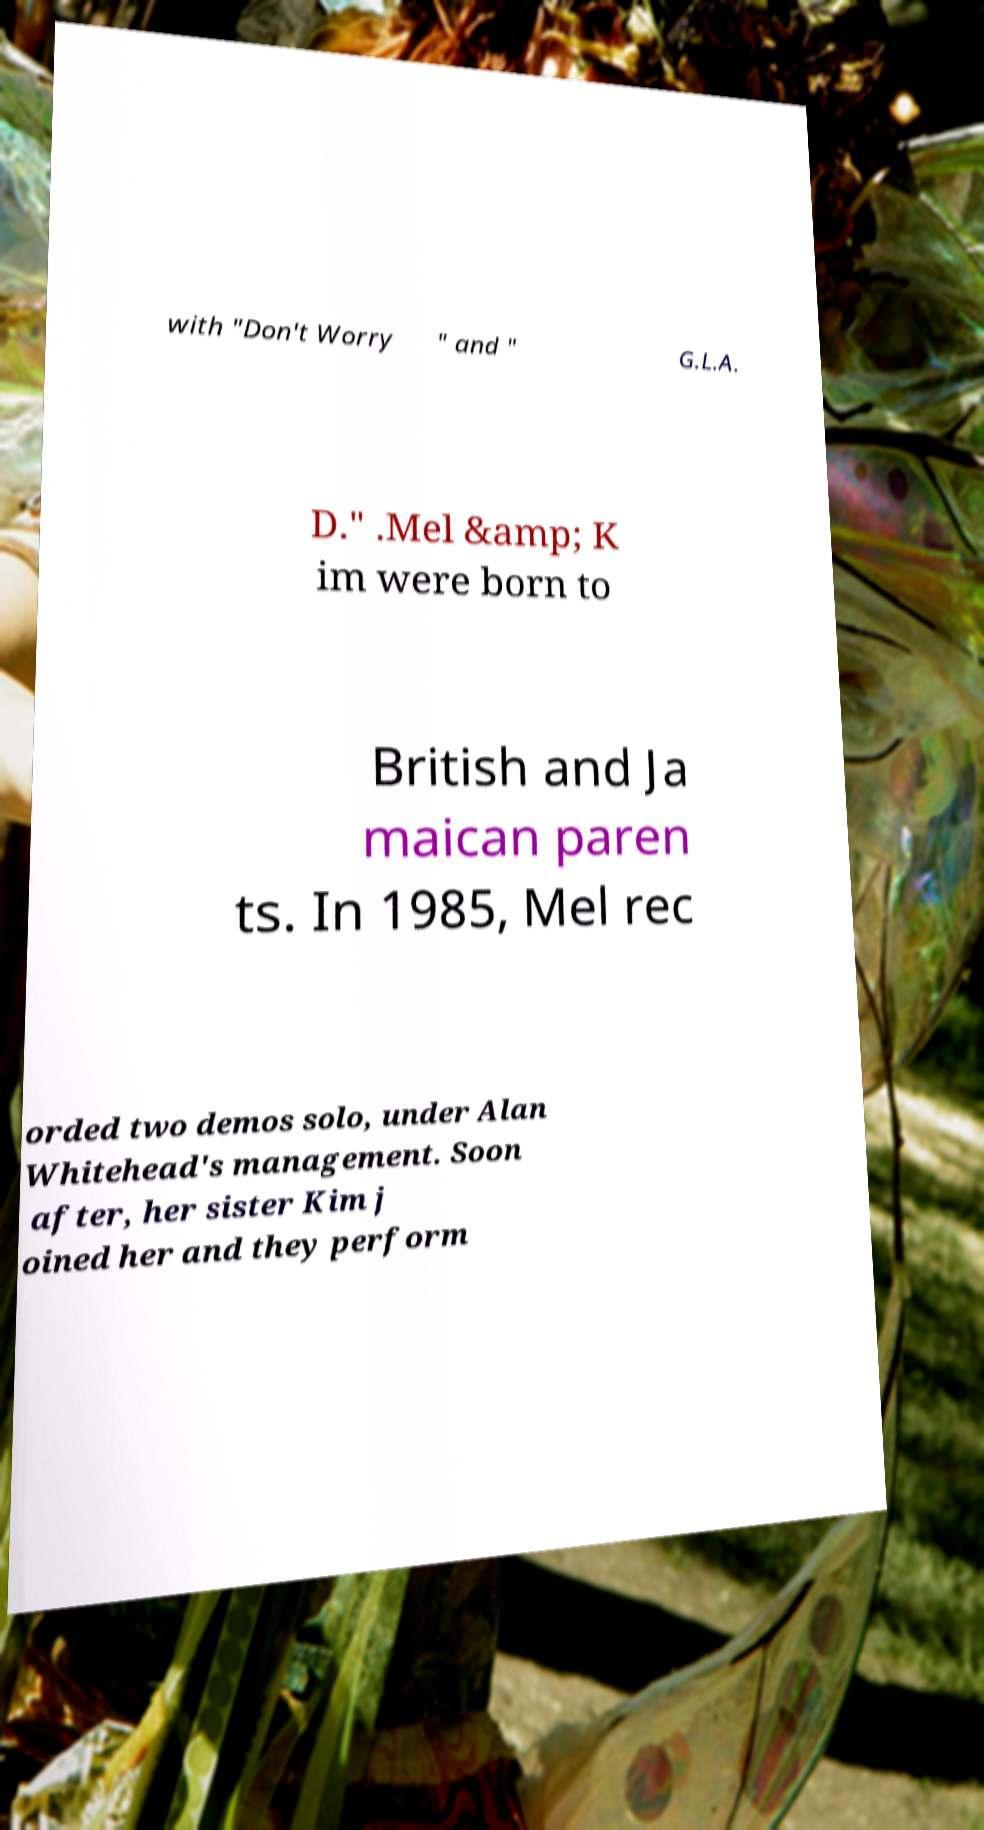What messages or text are displayed in this image? I need them in a readable, typed format. with "Don't Worry " and " G.L.A. D." .Mel &amp; K im were born to British and Ja maican paren ts. In 1985, Mel rec orded two demos solo, under Alan Whitehead's management. Soon after, her sister Kim j oined her and they perform 